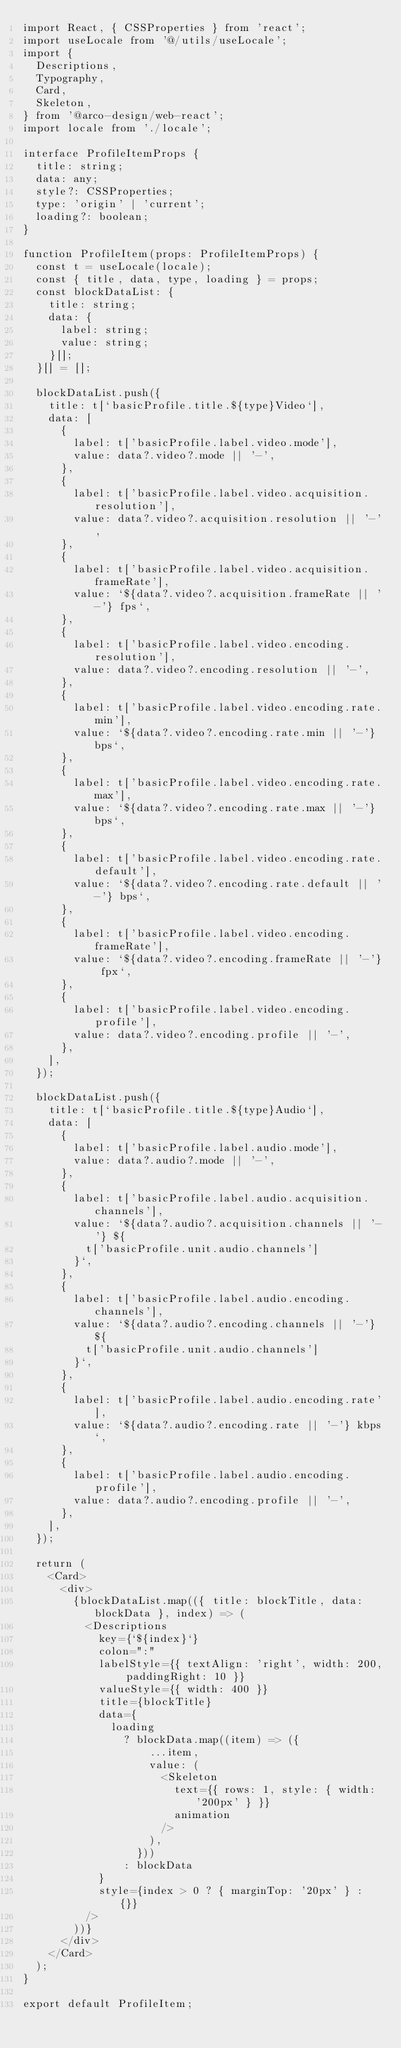Convert code to text. <code><loc_0><loc_0><loc_500><loc_500><_TypeScript_>import React, { CSSProperties } from 'react';
import useLocale from '@/utils/useLocale';
import {
  Descriptions,
  Typography,
  Card,
  Skeleton,
} from '@arco-design/web-react';
import locale from './locale';

interface ProfileItemProps {
  title: string;
  data: any;
  style?: CSSProperties;
  type: 'origin' | 'current';
  loading?: boolean;
}

function ProfileItem(props: ProfileItemProps) {
  const t = useLocale(locale);
  const { title, data, type, loading } = props;
  const blockDataList: {
    title: string;
    data: {
      label: string;
      value: string;
    }[];
  }[] = [];

  blockDataList.push({
    title: t[`basicProfile.title.${type}Video`],
    data: [
      {
        label: t['basicProfile.label.video.mode'],
        value: data?.video?.mode || '-',
      },
      {
        label: t['basicProfile.label.video.acquisition.resolution'],
        value: data?.video?.acquisition.resolution || '-',
      },
      {
        label: t['basicProfile.label.video.acquisition.frameRate'],
        value: `${data?.video?.acquisition.frameRate || '-'} fps`,
      },
      {
        label: t['basicProfile.label.video.encoding.resolution'],
        value: data?.video?.encoding.resolution || '-',
      },
      {
        label: t['basicProfile.label.video.encoding.rate.min'],
        value: `${data?.video?.encoding.rate.min || '-'} bps`,
      },
      {
        label: t['basicProfile.label.video.encoding.rate.max'],
        value: `${data?.video?.encoding.rate.max || '-'} bps`,
      },
      {
        label: t['basicProfile.label.video.encoding.rate.default'],
        value: `${data?.video?.encoding.rate.default || '-'} bps`,
      },
      {
        label: t['basicProfile.label.video.encoding.frameRate'],
        value: `${data?.video?.encoding.frameRate || '-'} fpx`,
      },
      {
        label: t['basicProfile.label.video.encoding.profile'],
        value: data?.video?.encoding.profile || '-',
      },
    ],
  });

  blockDataList.push({
    title: t[`basicProfile.title.${type}Audio`],
    data: [
      {
        label: t['basicProfile.label.audio.mode'],
        value: data?.audio?.mode || '-',
      },
      {
        label: t['basicProfile.label.audio.acquisition.channels'],
        value: `${data?.audio?.acquisition.channels || '-'} ${
          t['basicProfile.unit.audio.channels']
        }`,
      },
      {
        label: t['basicProfile.label.audio.encoding.channels'],
        value: `${data?.audio?.encoding.channels || '-'} ${
          t['basicProfile.unit.audio.channels']
        }`,
      },
      {
        label: t['basicProfile.label.audio.encoding.rate'],
        value: `${data?.audio?.encoding.rate || '-'} kbps`,
      },
      {
        label: t['basicProfile.label.audio.encoding.profile'],
        value: data?.audio?.encoding.profile || '-',
      },
    ],
  });

  return (
    <Card>
      <div>
        {blockDataList.map(({ title: blockTitle, data: blockData }, index) => (
          <Descriptions
            key={`${index}`}
            colon=":"
            labelStyle={{ textAlign: 'right', width: 200, paddingRight: 10 }}
            valueStyle={{ width: 400 }}
            title={blockTitle}
            data={
              loading
                ? blockData.map((item) => ({
                    ...item,
                    value: (
                      <Skeleton
                        text={{ rows: 1, style: { width: '200px' } }}
                        animation
                      />
                    ),
                  }))
                : blockData
            }
            style={index > 0 ? { marginTop: '20px' } : {}}
          />
        ))}
      </div>
    </Card>
  );
}

export default ProfileItem;
</code> 